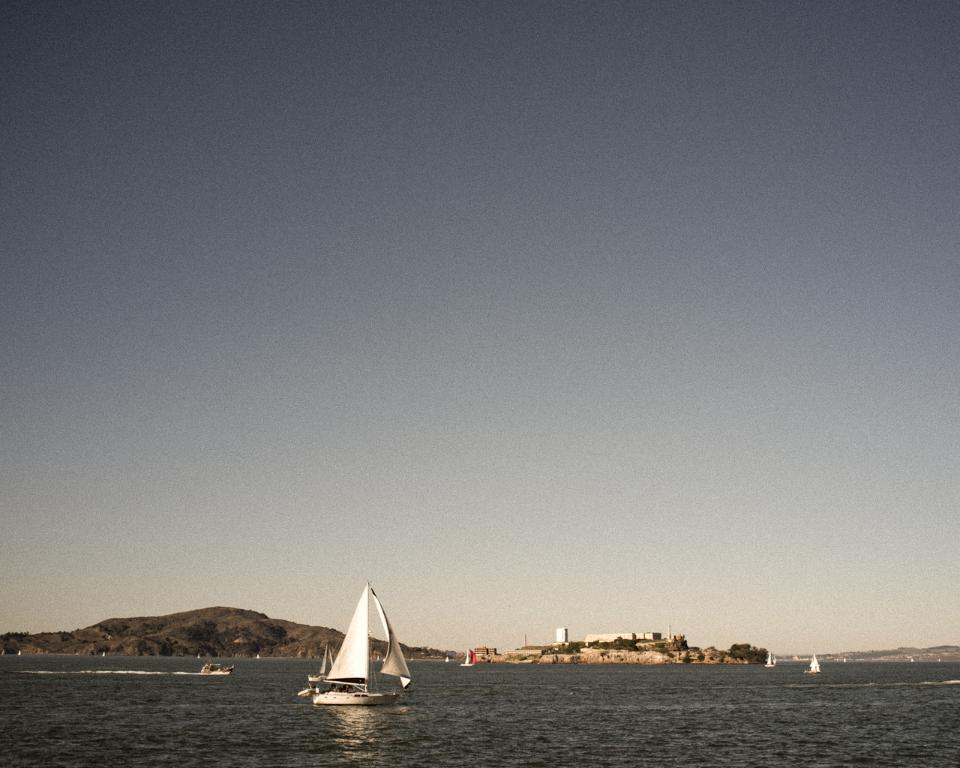What type of vehicles are in the image? There are boats in the image. Where are the boats located? The boats are on the water. What can be seen in the background of the image? There is a hill, at least one building, and the sky visible in the background of the image. How many hands are visible on the laborers in the image? There are no laborers or hands visible in the image; it features boats on the water with a background of a hill, building, and sky. 